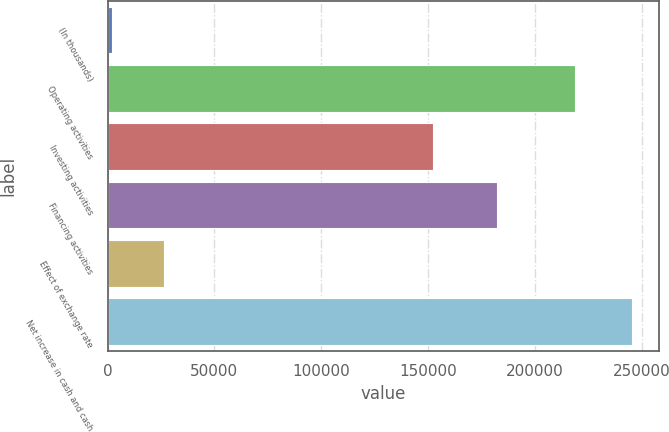<chart> <loc_0><loc_0><loc_500><loc_500><bar_chart><fcel>(In thousands)<fcel>Operating activities<fcel>Investing activities<fcel>Financing activities<fcel>Effect of exchange rate<fcel>Net increase in cash and cash<nl><fcel>2014<fcel>219033<fcel>152312<fcel>182306<fcel>26381.2<fcel>245686<nl></chart> 